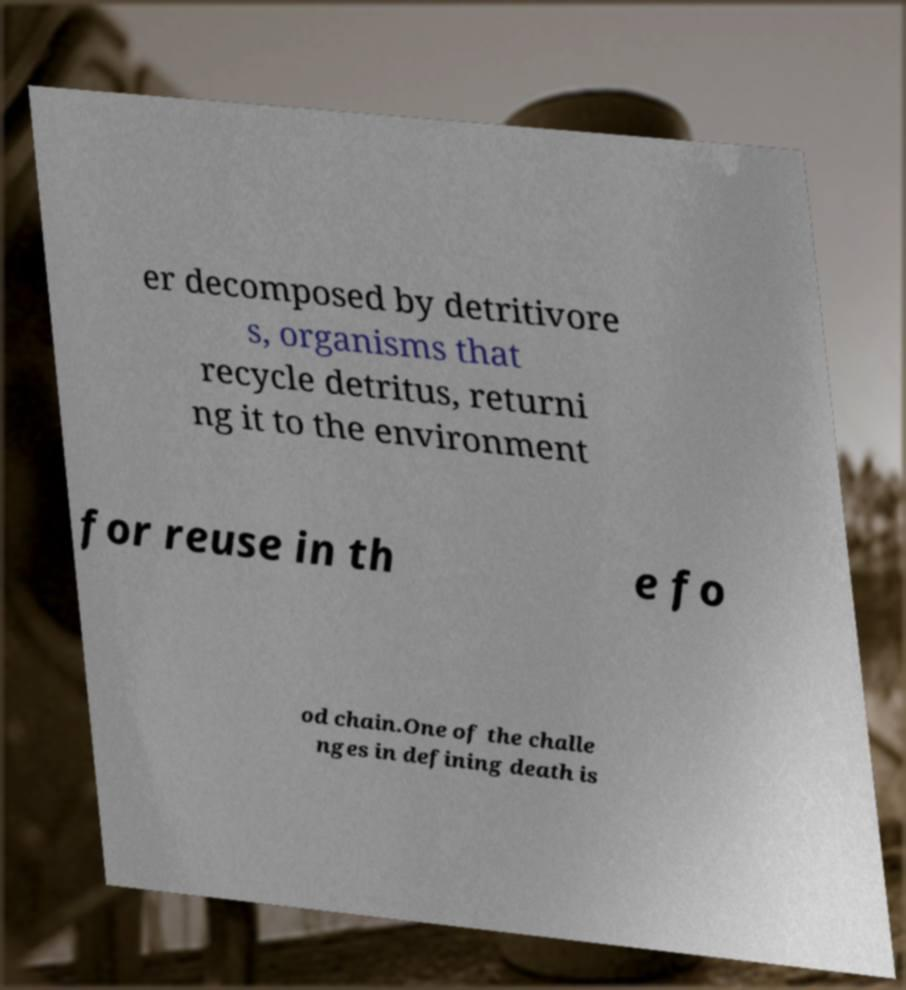Please identify and transcribe the text found in this image. er decomposed by detritivore s, organisms that recycle detritus, returni ng it to the environment for reuse in th e fo od chain.One of the challe nges in defining death is 